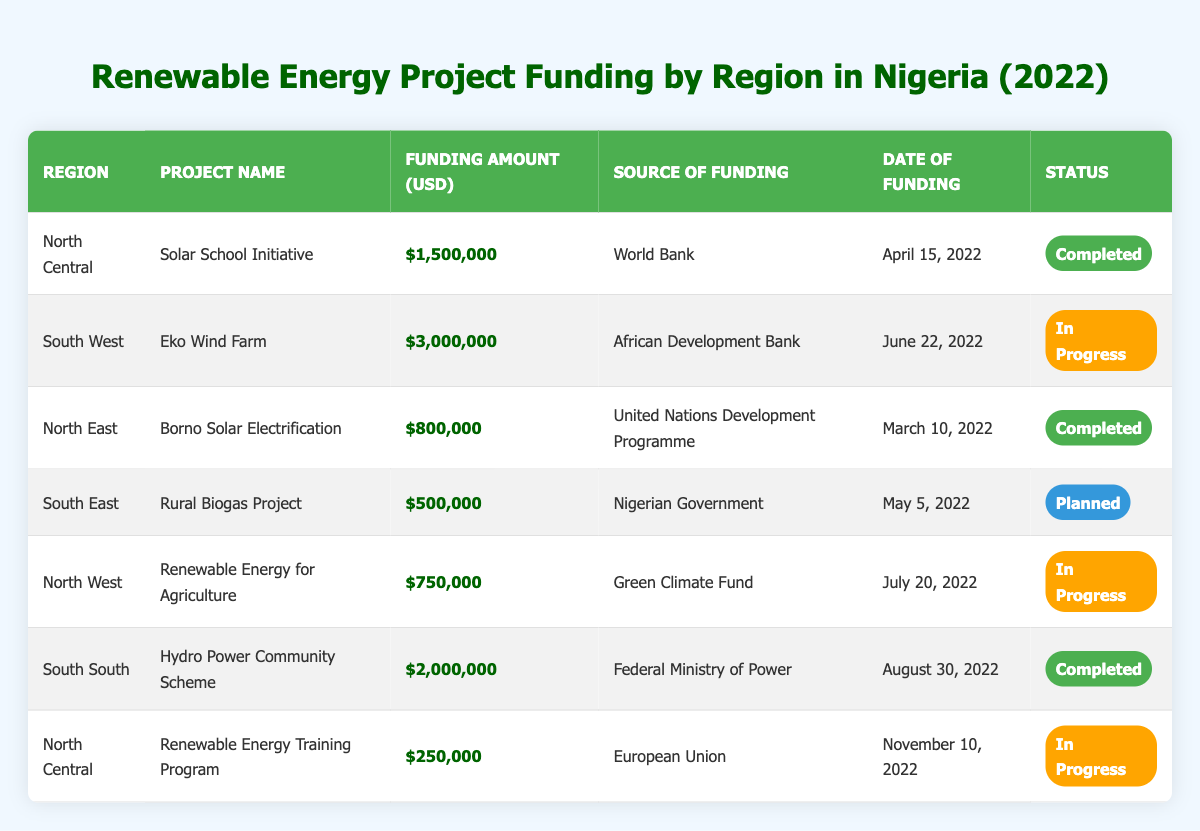What is the total funding amount for renewable energy projects in the North Central region? The projects in the North Central region are the Solar School Initiative ($1,500,000) and the Renewable Energy Training Program ($250,000). Adding these amounts together gives $1,500,000 + $250,000 = $1,750,000.
Answer: $1,750,000 Which project received the highest funding amount, and how much was it? The project with the highest funding amount is the Eko Wind Farm in the South West region, which received $3,000,000.
Answer: Eko Wind Farm, $3,000,000 How many projects are currently in progress? There are three projects classified as in progress: the Eko Wind Farm, Renewable Energy for Agriculture, and Renewable Energy Training Program.
Answer: 3 Is there a project funded by the Nigerian Government? Yes, the Rural Biogas Project in the South East region is funded by the Nigerian Government.
Answer: Yes What is the funding status of projects in the South South region? There is one project in the South South region, the Hydro Power Community Scheme, which has a status of completed.
Answer: Completed What is the funding amount for projects that are planned? There is only one planned project, the Rural Biogas Project, which has a funding amount of $500,000.
Answer: $500,000 Calculate the average funding amount of completed projects in the table. The completed projects are the Solar School Initiative ($1,500,000), Borno Solar Electrification ($800,000), and Hydro Power Community Scheme ($2,000,000). The total funding for completed projects is $1,500,000 + $800,000 + $2,000,000 = $4,300,000. There are 3 completed projects, so the average is $4,300,000 / 3 = $1,433,333.33.
Answer: $1,433,333.33 What percentage of the total funding amount came from the African Development Bank? The total funding is $1,500,000 (North Central) + $3,000,000 (South West) + $800,000 (North East) + $500,000 (South East) + $750,000 (North West) + $2,000,000 (South South) + $250,000 (North Central) = $8,800,000. The funding amount from the African Development Bank is $3,000,000. The percentage is ($3,000,000 / $8,800,000) * 100 = 34.09%.
Answer: 34.09% Which regions have projects that are planned? The only region with a planned project is the South East, corresponding to the Rural Biogas Project.
Answer: South East Are there more completed projects or in-progress projects in the table? There are four completed projects (Solar School Initiative, Borno Solar Electrification, Hydro Power Community Scheme, and the Renewable Energy Training Program) compared to three in-progress projects (Eko Wind Farm, Renewable Energy for Agriculture, and Renewable Energy Training Program). Therefore, there are more completed projects.
Answer: More completed projects 